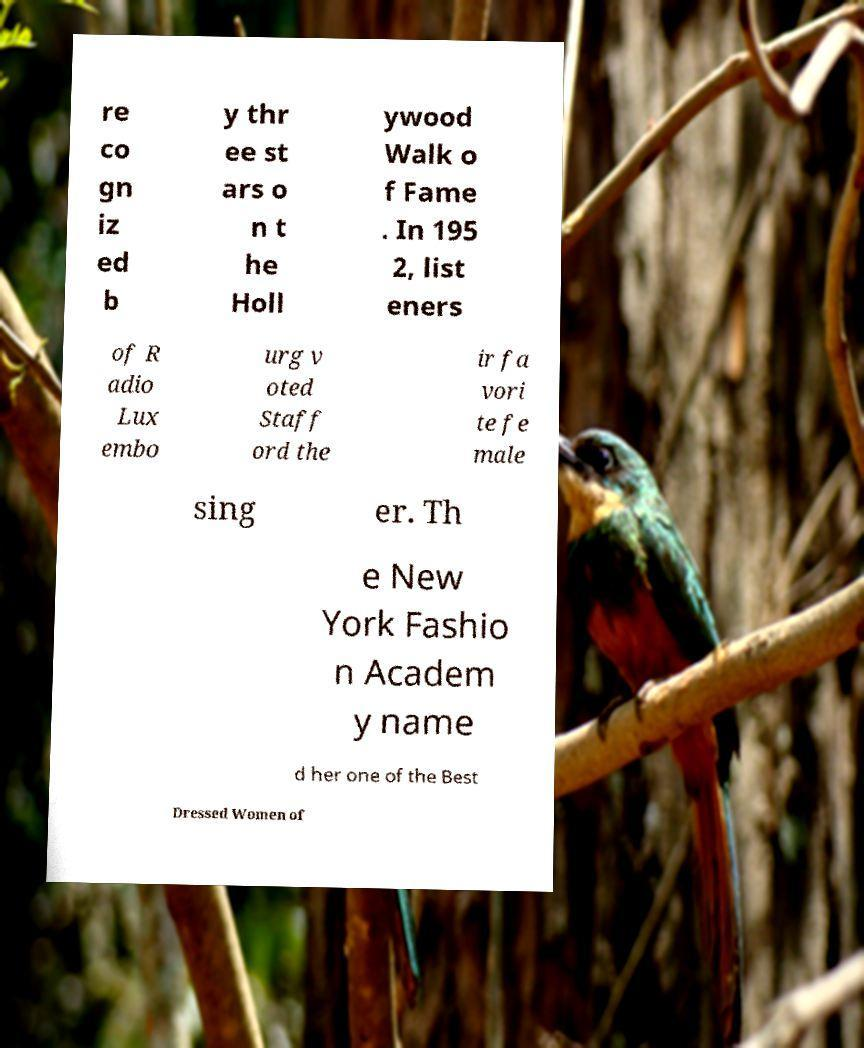Could you extract and type out the text from this image? re co gn iz ed b y thr ee st ars o n t he Holl ywood Walk o f Fame . In 195 2, list eners of R adio Lux embo urg v oted Staff ord the ir fa vori te fe male sing er. Th e New York Fashio n Academ y name d her one of the Best Dressed Women of 